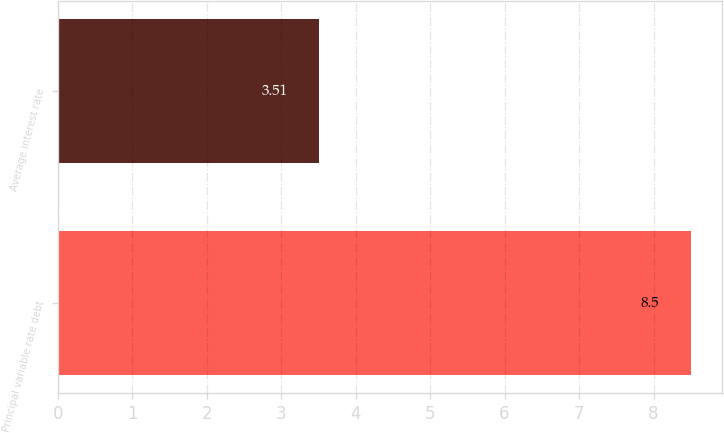Convert chart to OTSL. <chart><loc_0><loc_0><loc_500><loc_500><bar_chart><fcel>Principal variable rate debt<fcel>Average interest rate<nl><fcel>8.5<fcel>3.51<nl></chart> 